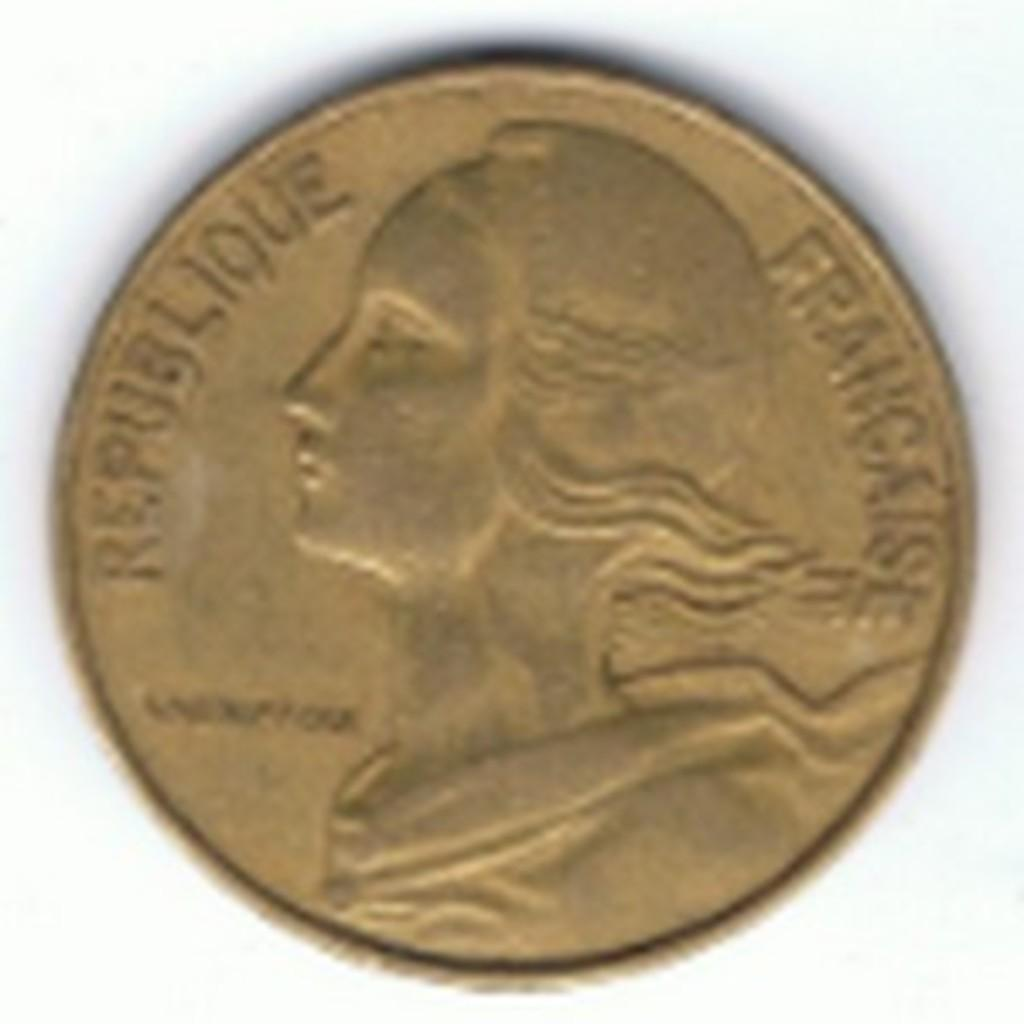<image>
Relay a brief, clear account of the picture shown. A coin has a woman's face and the words REPUBLIQUE FRANCAISE on it. 